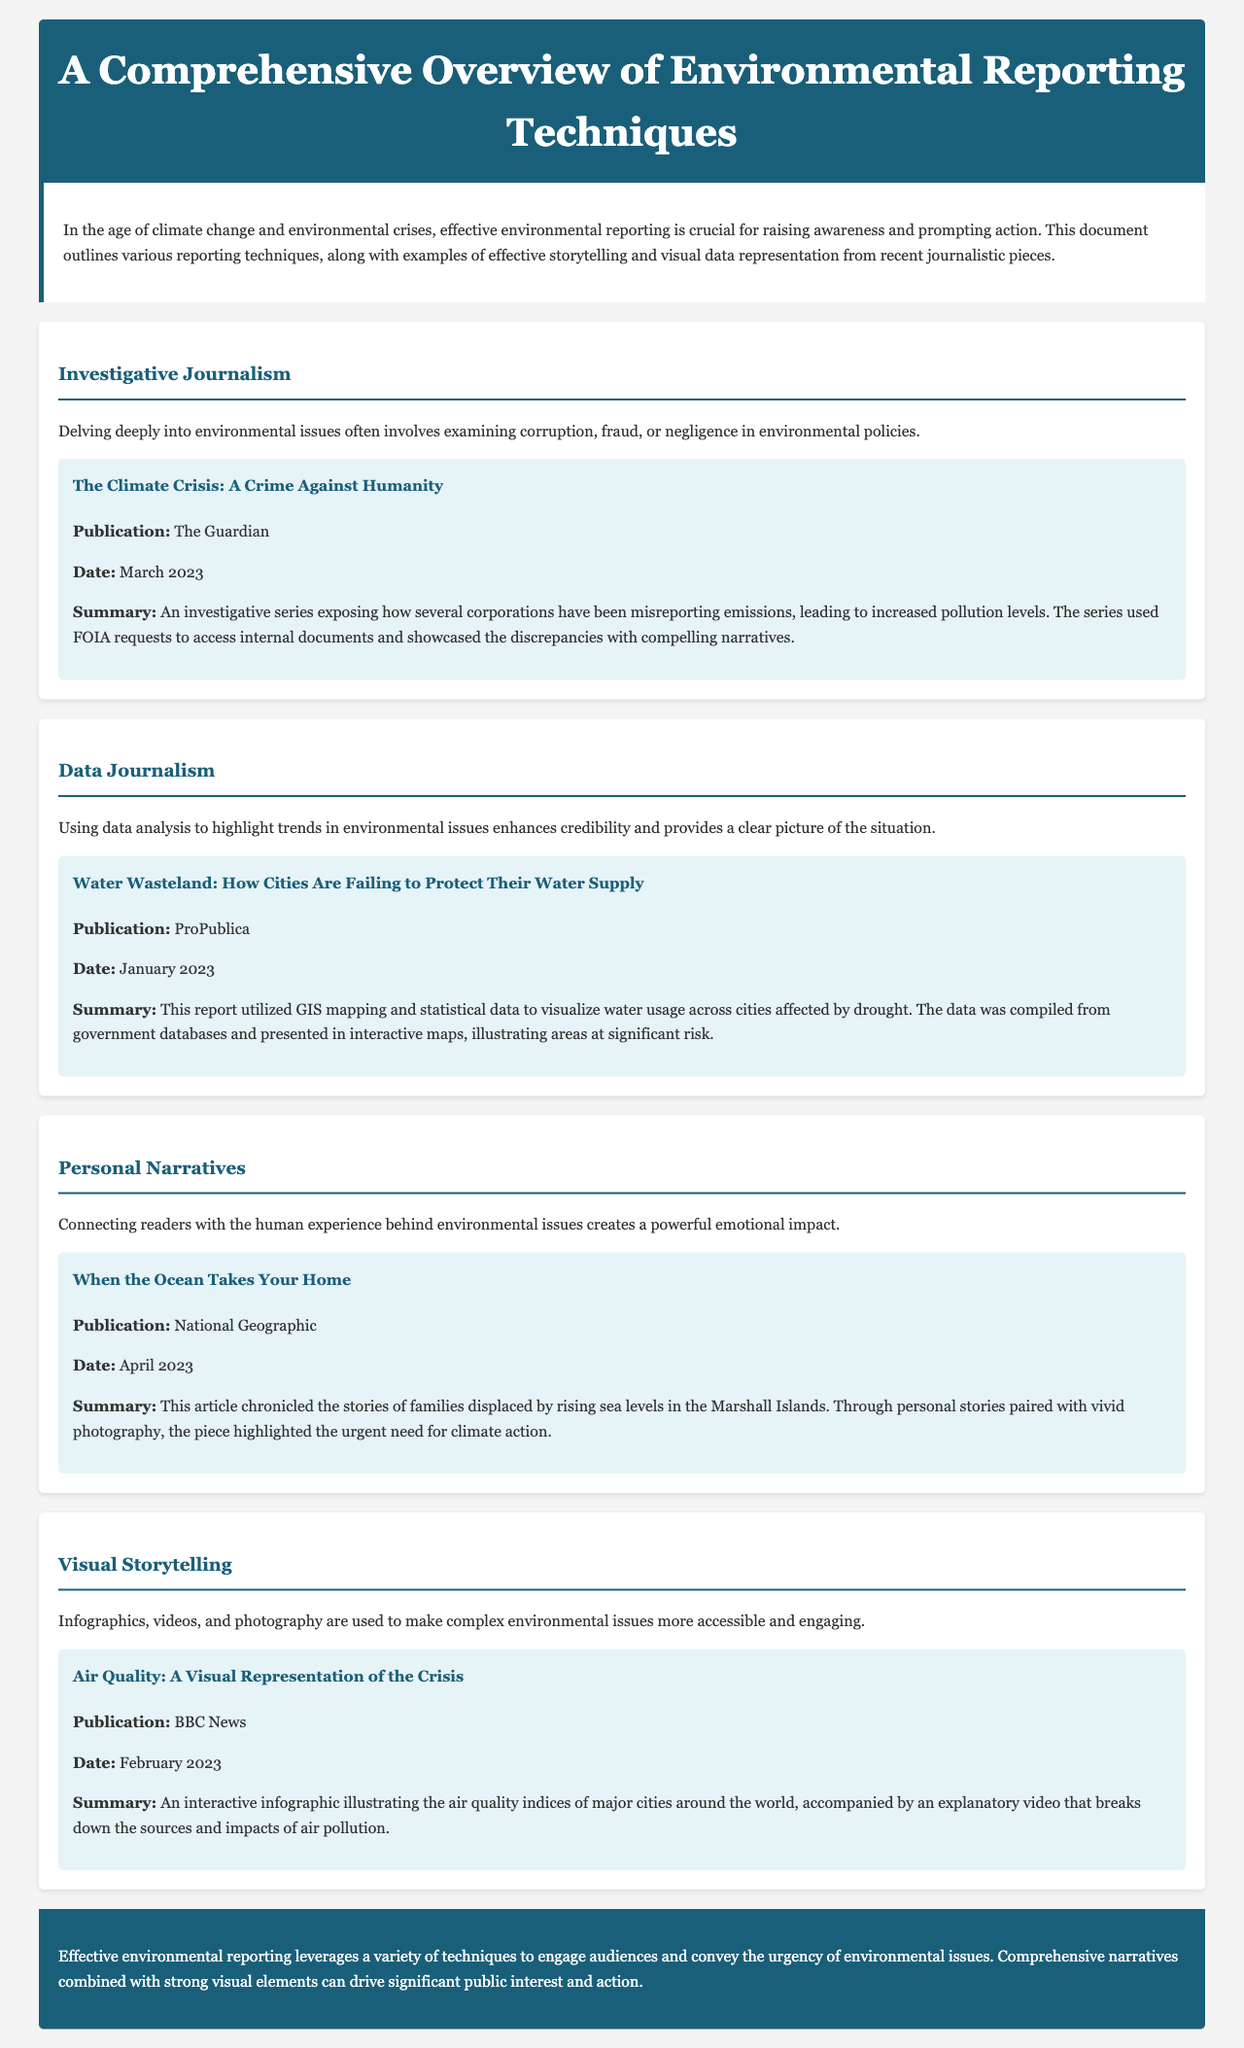What is the publication date of the article "The Climate Crisis: A Crime Against Humanity"? The publication date is indicated in the example section of the investigative journalism technique.
Answer: March 2023 What type of data representation was used in "Water Wasteland: How Cities Are Failing to Protect Their Water Supply"? The report mentions the use of GIS mapping and statistical data for data representation.
Answer: GIS mapping Who is the author behind "When the Ocean Takes Your Home"? The document provides the publication name but not the specific author's name, making it necessary to refer back to the publication for authorship.
Answer: National Geographic What is a key technique mentioned for engaging audiences in environmental reporting? The document lists various techniques, highlighting the importance of personal narratives for emotional impact.
Answer: Personal Narratives Which publication featured the interactive infographic on air quality? The title of the example includes the publication name alongside the date, providing clear attribution for each technique.
Answer: BBC News 